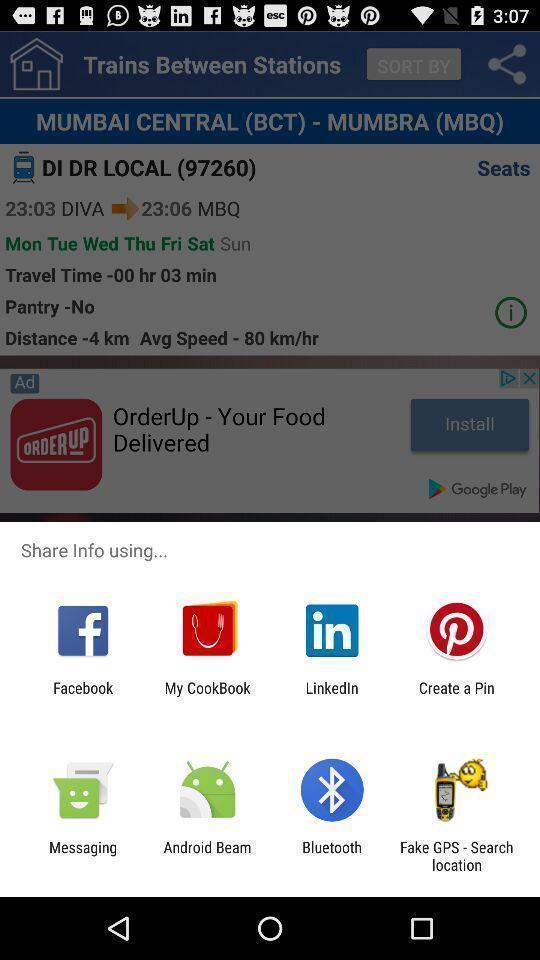Give me a summary of this screen capture. Various options of apps to share. 